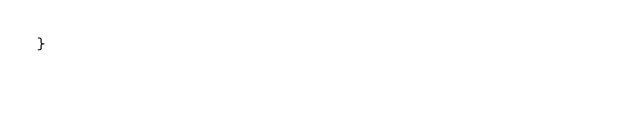<code> <loc_0><loc_0><loc_500><loc_500><_Kotlin_>}
</code> 